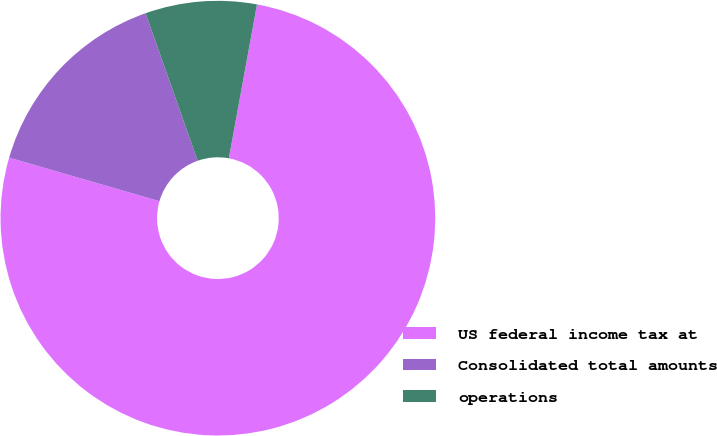Convert chart. <chart><loc_0><loc_0><loc_500><loc_500><pie_chart><fcel>US federal income tax at<fcel>Consolidated total amounts<fcel>operations<nl><fcel>76.61%<fcel>15.11%<fcel>8.28%<nl></chart> 